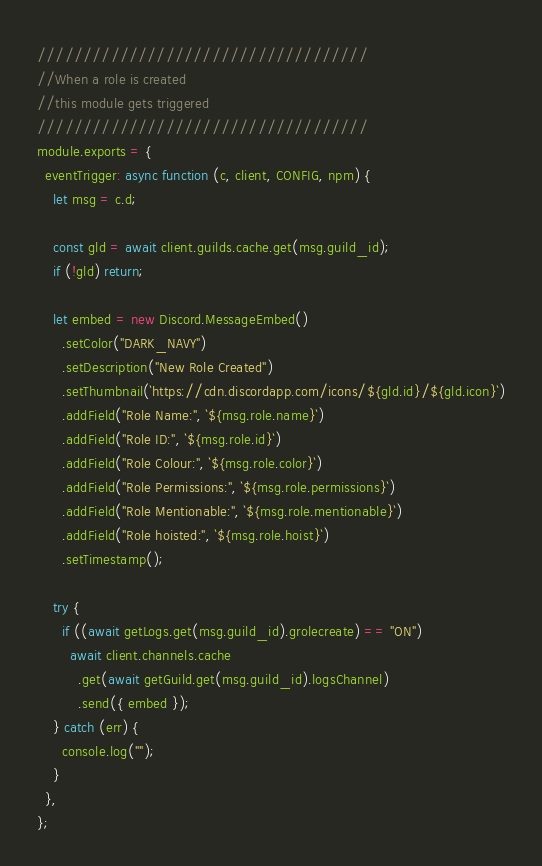Convert code to text. <code><loc_0><loc_0><loc_500><loc_500><_JavaScript_>////////////////////////////////////
//When a role is created
//this module gets triggered
////////////////////////////////////
module.exports = {
  eventTrigger: async function (c, client, CONFIG, npm) {
    let msg = c.d;

    const gld = await client.guilds.cache.get(msg.guild_id);
    if (!gld) return;

    let embed = new Discord.MessageEmbed()
      .setColor("DARK_NAVY")
      .setDescription("New Role Created")
      .setThumbnail(`https://cdn.discordapp.com/icons/${gld.id}/${gld.icon}`)
      .addField("Role Name:", `${msg.role.name}`)
      .addField("Role ID:", `${msg.role.id}`)
      .addField("Role Colour:", `${msg.role.color}`)
      .addField("Role Permissions:", `${msg.role.permissions}`)
      .addField("Role Mentionable:", `${msg.role.mentionable}`)
      .addField("Role hoisted:", `${msg.role.hoist}`)
      .setTimestamp();

    try {
      if ((await getLogs.get(msg.guild_id).grolecreate) == "ON")
        await client.channels.cache
          .get(await getGuild.get(msg.guild_id).logsChannel)
          .send({ embed });
    } catch (err) {
      console.log("");
    }
  },
};
</code> 